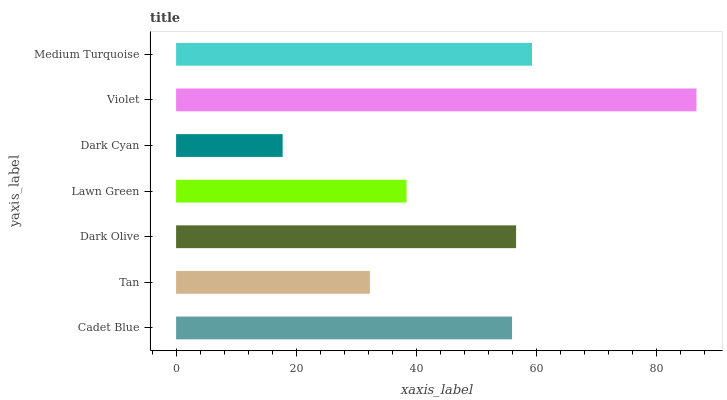Is Dark Cyan the minimum?
Answer yes or no. Yes. Is Violet the maximum?
Answer yes or no. Yes. Is Tan the minimum?
Answer yes or no. No. Is Tan the maximum?
Answer yes or no. No. Is Cadet Blue greater than Tan?
Answer yes or no. Yes. Is Tan less than Cadet Blue?
Answer yes or no. Yes. Is Tan greater than Cadet Blue?
Answer yes or no. No. Is Cadet Blue less than Tan?
Answer yes or no. No. Is Cadet Blue the high median?
Answer yes or no. Yes. Is Cadet Blue the low median?
Answer yes or no. Yes. Is Dark Cyan the high median?
Answer yes or no. No. Is Lawn Green the low median?
Answer yes or no. No. 